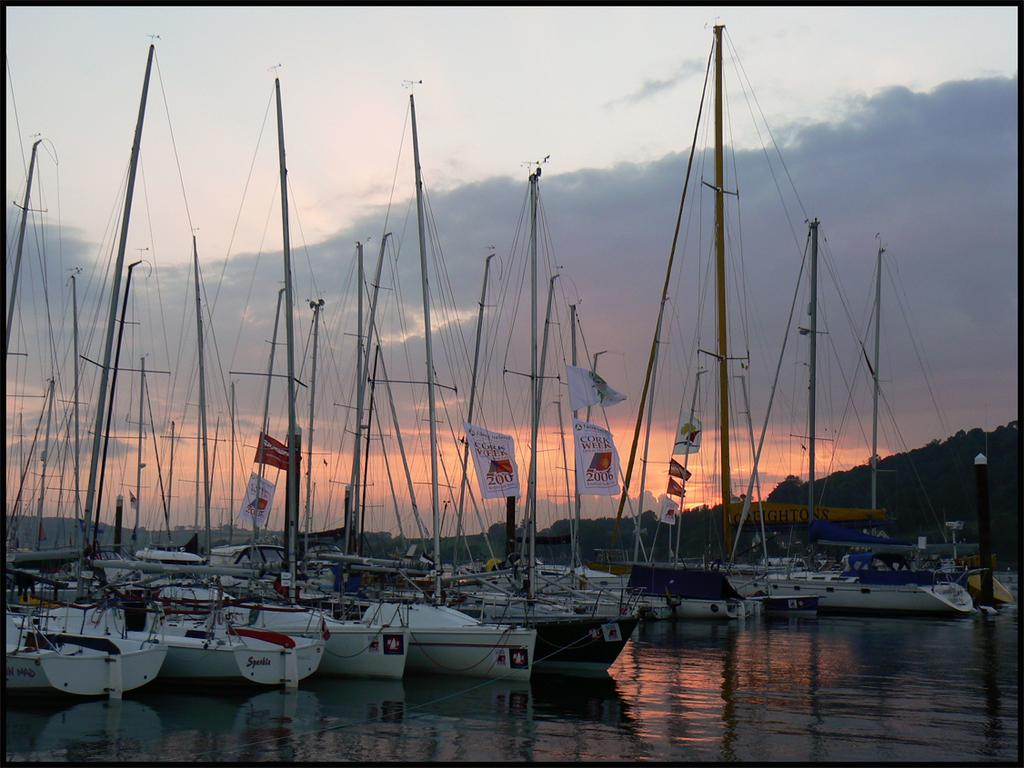<image>
Share a concise interpretation of the image provided. a lot of boats with a sign saying cork week 2016 ON A BANNER 